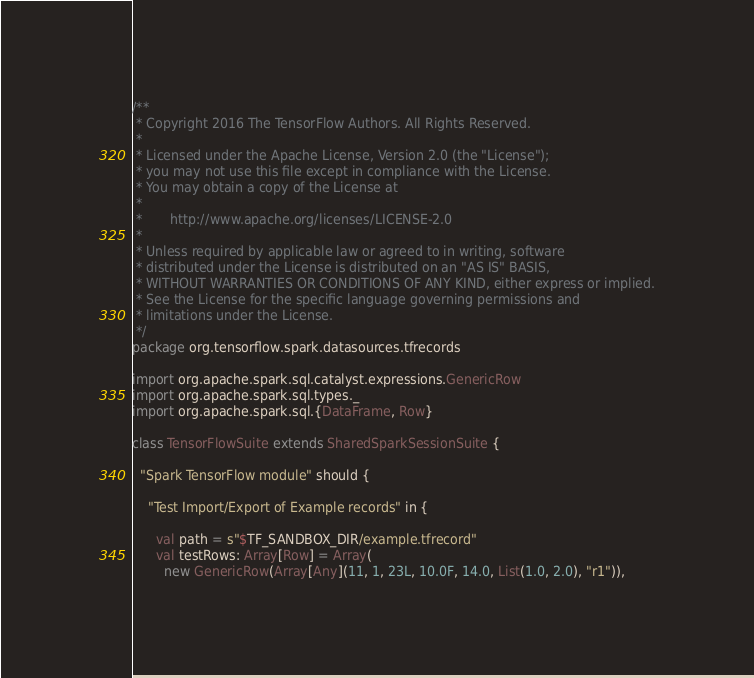Convert code to text. <code><loc_0><loc_0><loc_500><loc_500><_Scala_>/**
 * Copyright 2016 The TensorFlow Authors. All Rights Reserved.
 *
 * Licensed under the Apache License, Version 2.0 (the "License");
 * you may not use this file except in compliance with the License.
 * You may obtain a copy of the License at
 *
 *       http://www.apache.org/licenses/LICENSE-2.0
 *
 * Unless required by applicable law or agreed to in writing, software
 * distributed under the License is distributed on an "AS IS" BASIS,
 * WITHOUT WARRANTIES OR CONDITIONS OF ANY KIND, either express or implied.
 * See the License for the specific language governing permissions and
 * limitations under the License.
 */
package org.tensorflow.spark.datasources.tfrecords

import org.apache.spark.sql.catalyst.expressions.GenericRow
import org.apache.spark.sql.types._
import org.apache.spark.sql.{DataFrame, Row}

class TensorFlowSuite extends SharedSparkSessionSuite {

  "Spark TensorFlow module" should {

    "Test Import/Export of Example records" in {

      val path = s"$TF_SANDBOX_DIR/example.tfrecord"
      val testRows: Array[Row] = Array(
        new GenericRow(Array[Any](11, 1, 23L, 10.0F, 14.0, List(1.0, 2.0), "r1")),</code> 